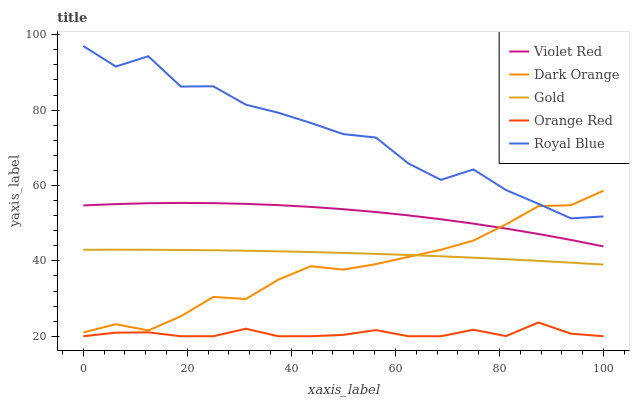Does Orange Red have the minimum area under the curve?
Answer yes or no. Yes. Does Royal Blue have the maximum area under the curve?
Answer yes or no. Yes. Does Violet Red have the minimum area under the curve?
Answer yes or no. No. Does Violet Red have the maximum area under the curve?
Answer yes or no. No. Is Gold the smoothest?
Answer yes or no. Yes. Is Royal Blue the roughest?
Answer yes or no. Yes. Is Violet Red the smoothest?
Answer yes or no. No. Is Violet Red the roughest?
Answer yes or no. No. Does Orange Red have the lowest value?
Answer yes or no. Yes. Does Violet Red have the lowest value?
Answer yes or no. No. Does Royal Blue have the highest value?
Answer yes or no. Yes. Does Violet Red have the highest value?
Answer yes or no. No. Is Gold less than Royal Blue?
Answer yes or no. Yes. Is Royal Blue greater than Violet Red?
Answer yes or no. Yes. Does Gold intersect Dark Orange?
Answer yes or no. Yes. Is Gold less than Dark Orange?
Answer yes or no. No. Is Gold greater than Dark Orange?
Answer yes or no. No. Does Gold intersect Royal Blue?
Answer yes or no. No. 